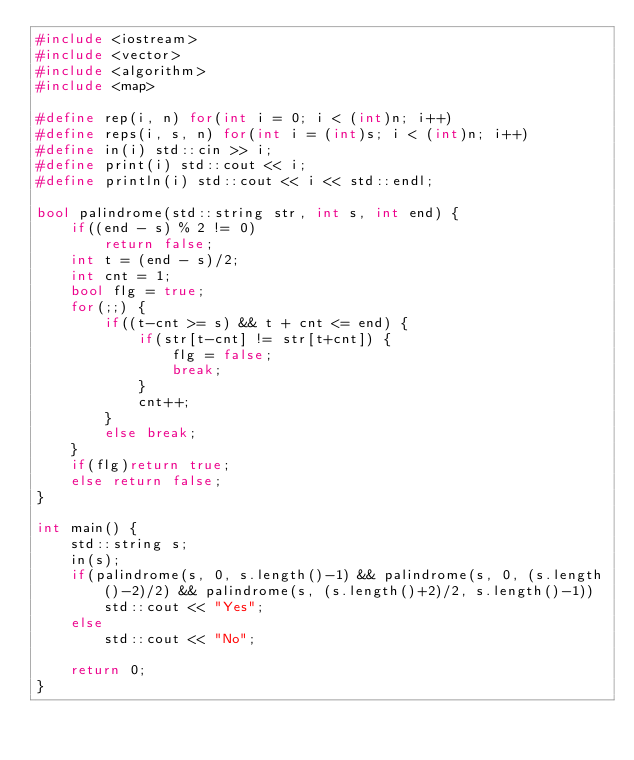Convert code to text. <code><loc_0><loc_0><loc_500><loc_500><_C++_>#include <iostream>
#include <vector>
#include <algorithm>
#include <map>

#define rep(i, n) for(int i = 0; i < (int)n; i++)
#define reps(i, s, n) for(int i = (int)s; i < (int)n; i++)
#define in(i) std::cin >> i;
#define print(i) std::cout << i;
#define println(i) std::cout << i << std::endl;

bool palindrome(std::string str, int s, int end) {
    if((end - s) % 2 != 0)
        return false;
    int t = (end - s)/2;
    int cnt = 1;
    bool flg = true;
    for(;;) {
        if((t-cnt >= s) && t + cnt <= end) {
            if(str[t-cnt] != str[t+cnt]) {
                flg = false;
                break;
            }
            cnt++;
        }
        else break;
    }
    if(flg)return true;
    else return false;
}

int main() {
    std::string s;
    in(s);
    if(palindrome(s, 0, s.length()-1) && palindrome(s, 0, (s.length()-2)/2) && palindrome(s, (s.length()+2)/2, s.length()-1))
        std::cout << "Yes";
    else
        std::cout << "No";
       
    return 0;
}</code> 